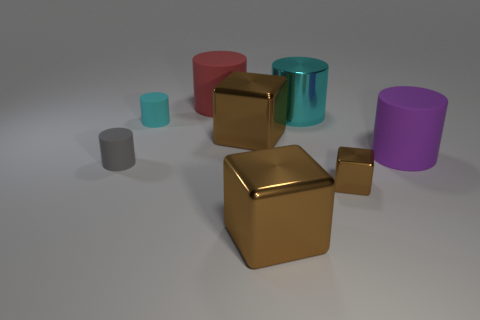The small rubber thing that is the same color as the big metallic cylinder is what shape?
Give a very brief answer. Cylinder. Are there any cyan metal cylinders of the same size as the red matte cylinder?
Your answer should be very brief. Yes. There is a big rubber thing that is behind the cyan matte thing; how many small gray rubber cylinders are behind it?
Offer a terse response. 0. What material is the red thing?
Offer a very short reply. Rubber. There is a small shiny object; what number of big things are on the left side of it?
Give a very brief answer. 4. What number of tiny rubber objects are the same color as the metallic cylinder?
Make the answer very short. 1. Are there more large cyan things than large brown cubes?
Your answer should be very brief. No. How big is the cylinder that is to the right of the small gray cylinder and to the left of the red thing?
Give a very brief answer. Small. Is the cyan cylinder behind the cyan matte object made of the same material as the cyan cylinder that is on the left side of the large red matte object?
Your response must be concise. No. There is a metallic thing that is the same size as the cyan matte cylinder; what shape is it?
Provide a succinct answer. Cube. 